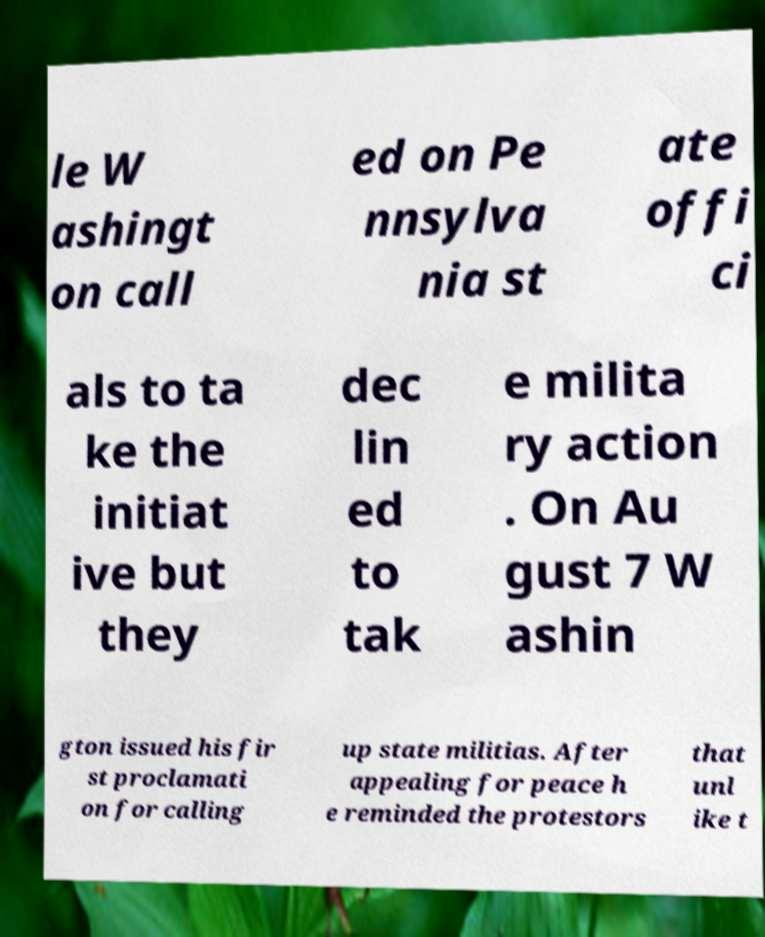Please read and relay the text visible in this image. What does it say? le W ashingt on call ed on Pe nnsylva nia st ate offi ci als to ta ke the initiat ive but they dec lin ed to tak e milita ry action . On Au gust 7 W ashin gton issued his fir st proclamati on for calling up state militias. After appealing for peace h e reminded the protestors that unl ike t 